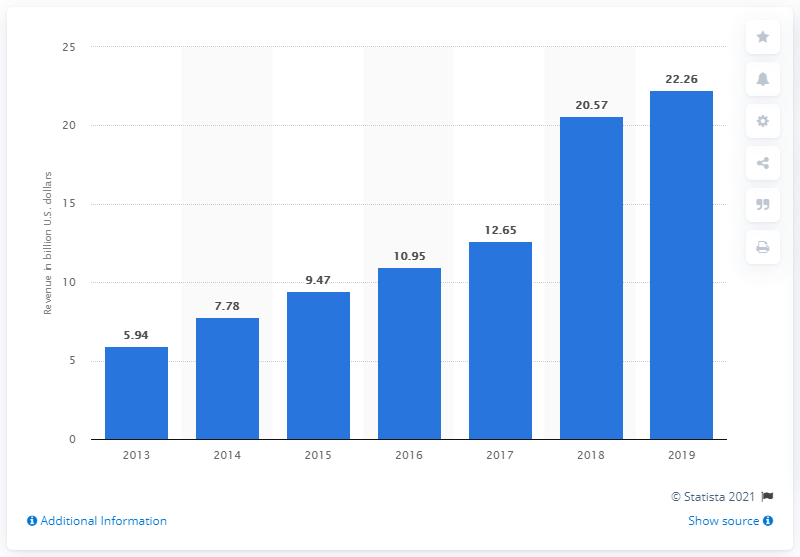Mention a couple of crucial points in this snapshot. Lennar Corporation reported a net income of 22.26 billion dollars in Fiscal Year 2019. 